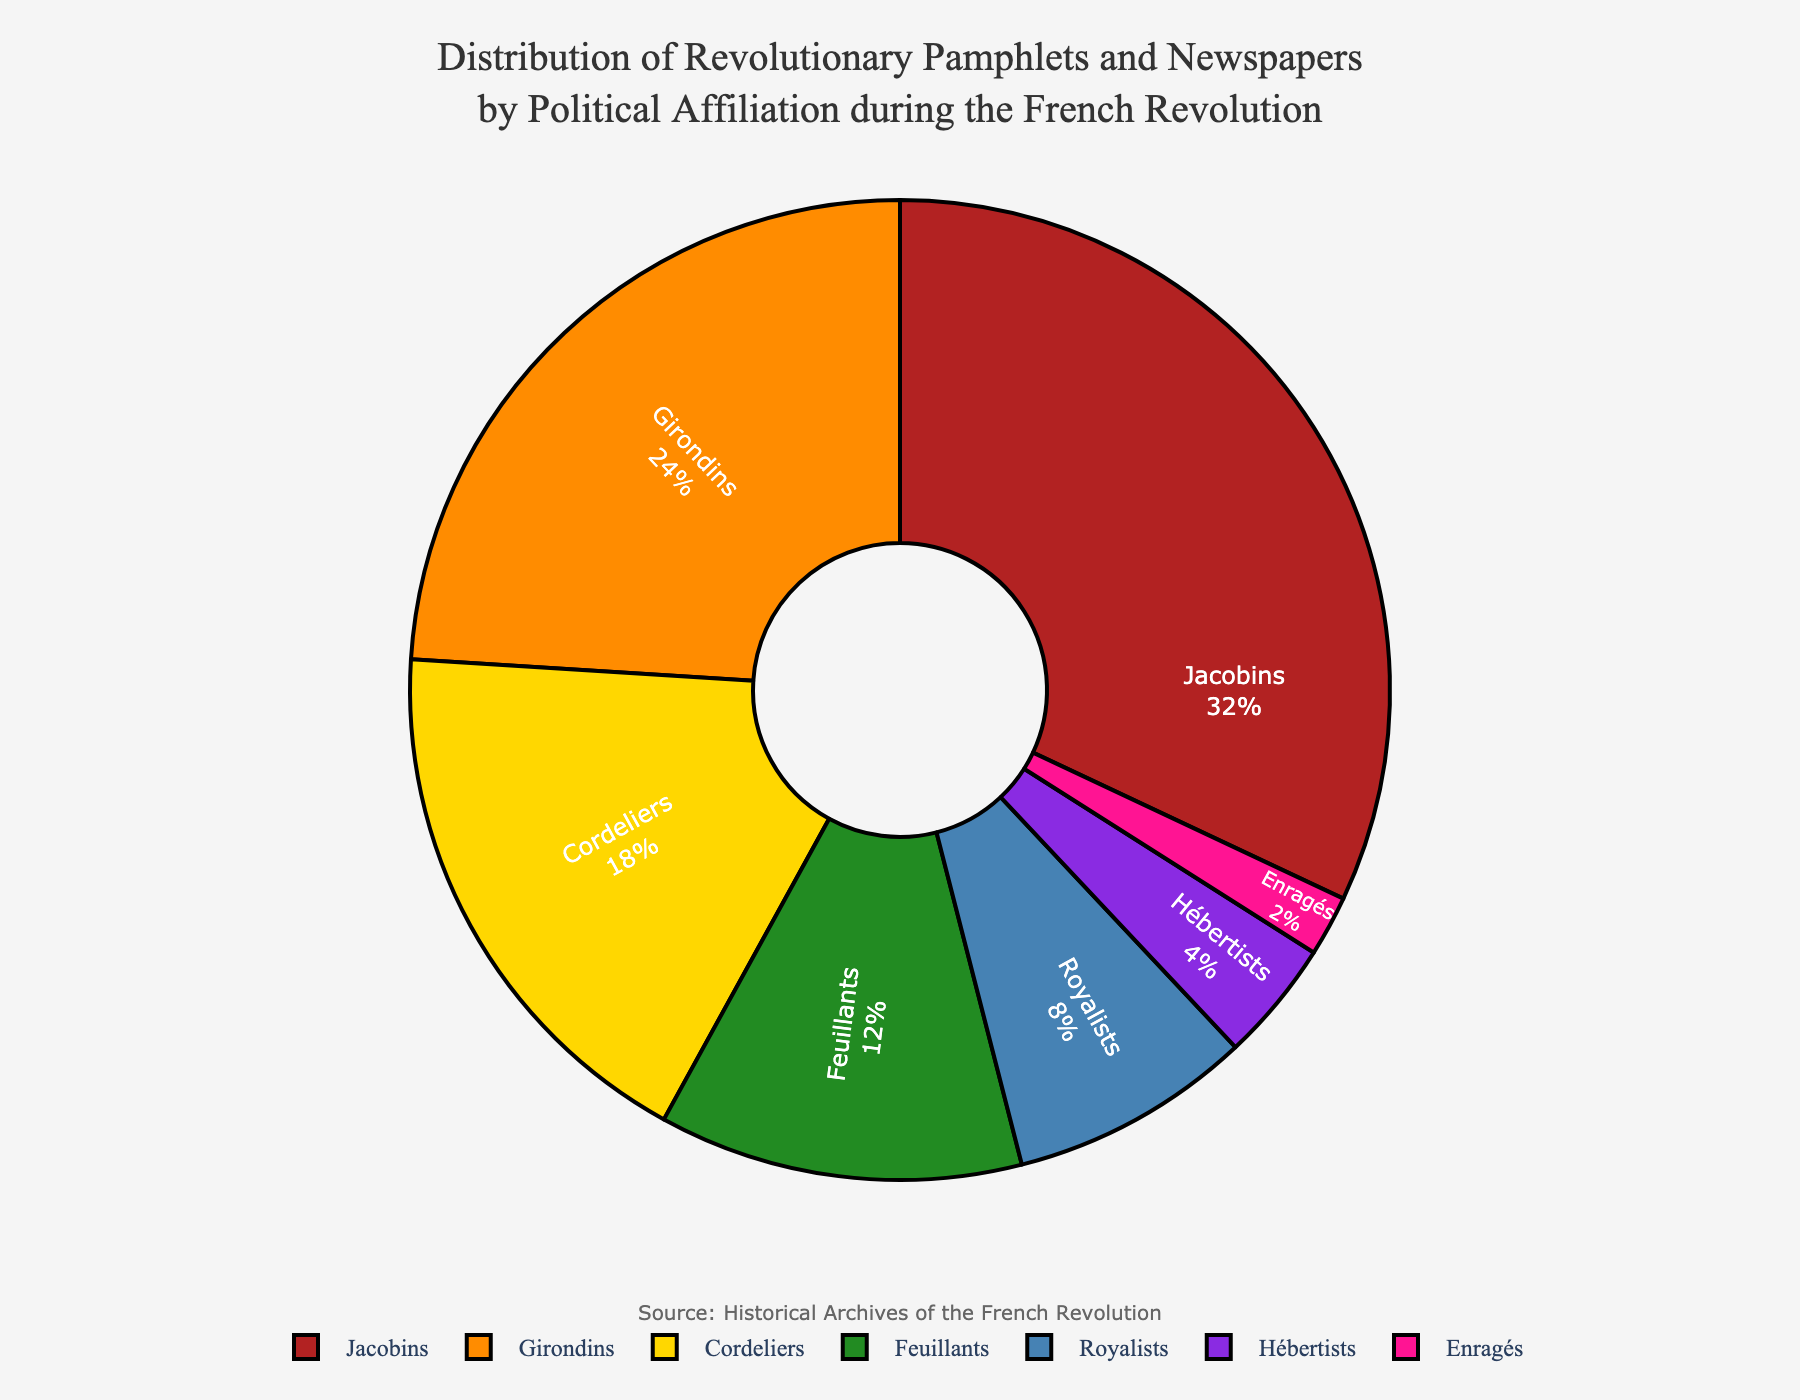What percentage of total pamphlets and newspapers were published by the Jacobins and Girondins combined? The percentage for the Jacobins is 32% and for the Girondins is 24%. Adding these two percentages together (32% + 24%) gives a total of 56%.
Answer: 56% Which political group published the fewest pamphlets and newspapers? By looking at the pie chart, the Enragés have the smallest segment with 2%.
Answer: Enragés Are the Cordeliers or the Feuillants responsible for a higher percentage of publications? The Cordeliers published 18% of the pamphlets and newspapers, while the Feuillants published 12%. So, the Cordeliers are responsible for a higher percentage.
Answer: Cordeliers How much greater is the percentage of pamphlets and newspapers published by Royalists compared to Hébertists? The percentage for Royalists is 8%, and for Hébertists, it is 4%. The difference is 8% - 4%, which is 4%.
Answer: 4% What is the sum of the percentages for the Cordeliers, Feuillants, and Hébertists? Adding the percentages for the Cordeliers (18%), Feuillants (12%), and Hébertists (4%) gives a total of 18% + 12% + 4% = 34%.
Answer: 34% Which political groups' combined total publications are less than the Jacobins alone? The Jacobins published 32%. Adding the percentages for the Feuillants (12%), Royalists (8%), Hébertists (4%), and Enragés (2%) gives 12% + 8% + 4% + 2% = 26%, which is less than 32%.
Answer: Feuillants, Royalists, Hébertists, Enragés What proportion of publications were made by radical political groups (Jacobins, Hébertists, Enragés)? Adding the percentages of the Jacobins (32%), Hébertists (4%), and Enragés (2%) gives a total of 32% + 4% + 2% = 38%.
Answer: 38% 